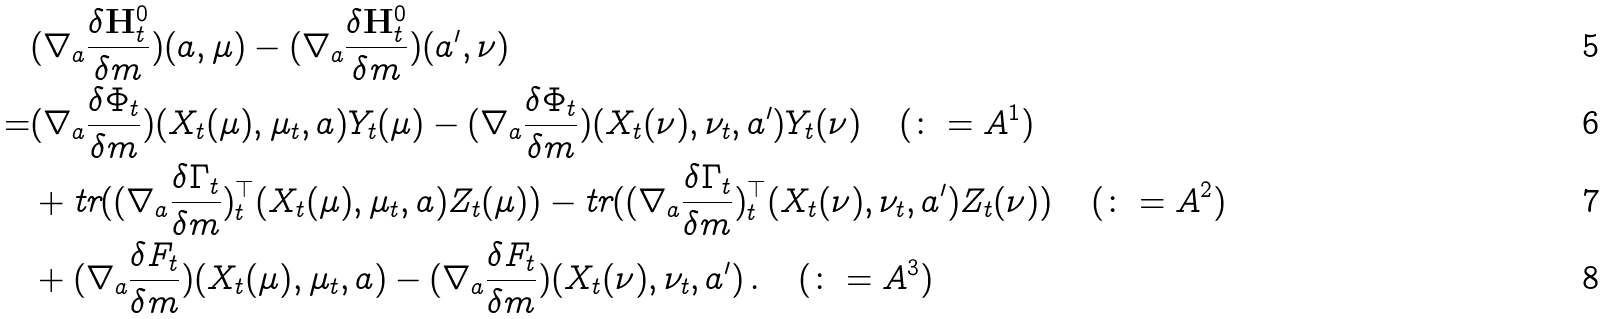Convert formula to latex. <formula><loc_0><loc_0><loc_500><loc_500>& ( \nabla _ { a } \frac { \delta \mathbf H _ { t } ^ { 0 } } { \delta m } ) ( a , \mu ) - ( \nabla _ { a } \frac { \delta \mathbf H _ { t } ^ { 0 } } { \delta m } ) ( a ^ { \prime } , \nu ) \\ = & ( \nabla _ { a } \frac { \delta \Phi _ { t } } { \delta m } ) ( X _ { t } ( \mu ) , \mu _ { t } , a ) Y _ { t } ( \mu ) - ( \nabla _ { a } \frac { \delta \Phi _ { t } } { \delta m } ) ( X _ { t } ( \nu ) , \nu _ { t } , a ^ { \prime } ) Y _ { t } ( \nu ) \quad ( \colon = A ^ { 1 } ) \\ & + \text {tr} ( ( \nabla _ { a } \frac { \delta \Gamma _ { t } } { \delta m } ) ^ { \top } _ { t } ( X _ { t } ( \mu ) , \mu _ { t } , a ) Z _ { t } ( \mu ) ) - \text {tr} ( ( \nabla _ { a } \frac { \delta \Gamma _ { t } } { \delta m } ) ^ { \top } _ { t } ( X _ { t } ( \nu ) , \nu _ { t } , a ^ { \prime } ) Z _ { t } ( \nu ) ) \quad ( \colon = A ^ { 2 } ) \\ & + ( \nabla _ { a } \frac { \delta F _ { t } } { \delta m } ) ( X _ { t } ( \mu ) , \mu _ { t } , a ) - ( \nabla _ { a } \frac { \delta F _ { t } } { \delta m } ) ( X _ { t } ( \nu ) , \nu _ { t } , a ^ { \prime } ) \, . \quad ( \colon = A ^ { 3 } )</formula> 